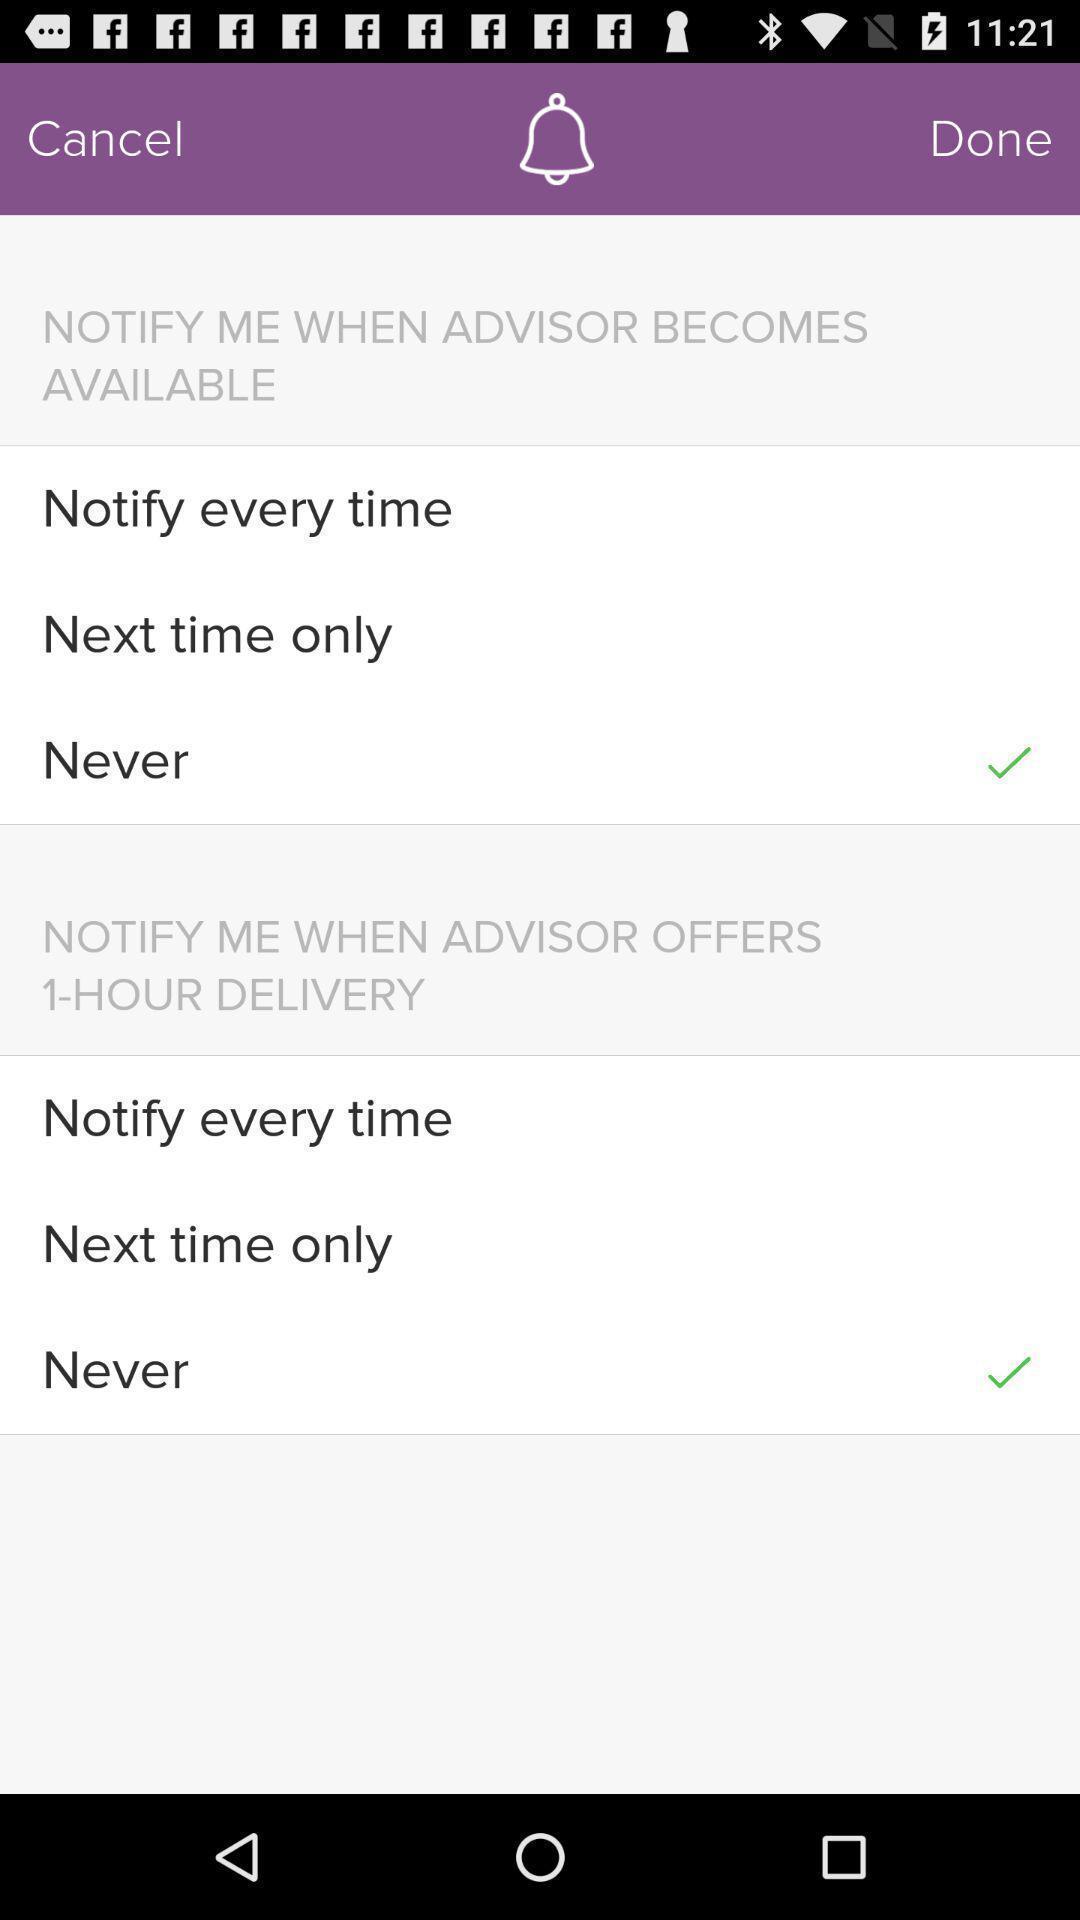What details can you identify in this image? Page displays notification settings in app. 